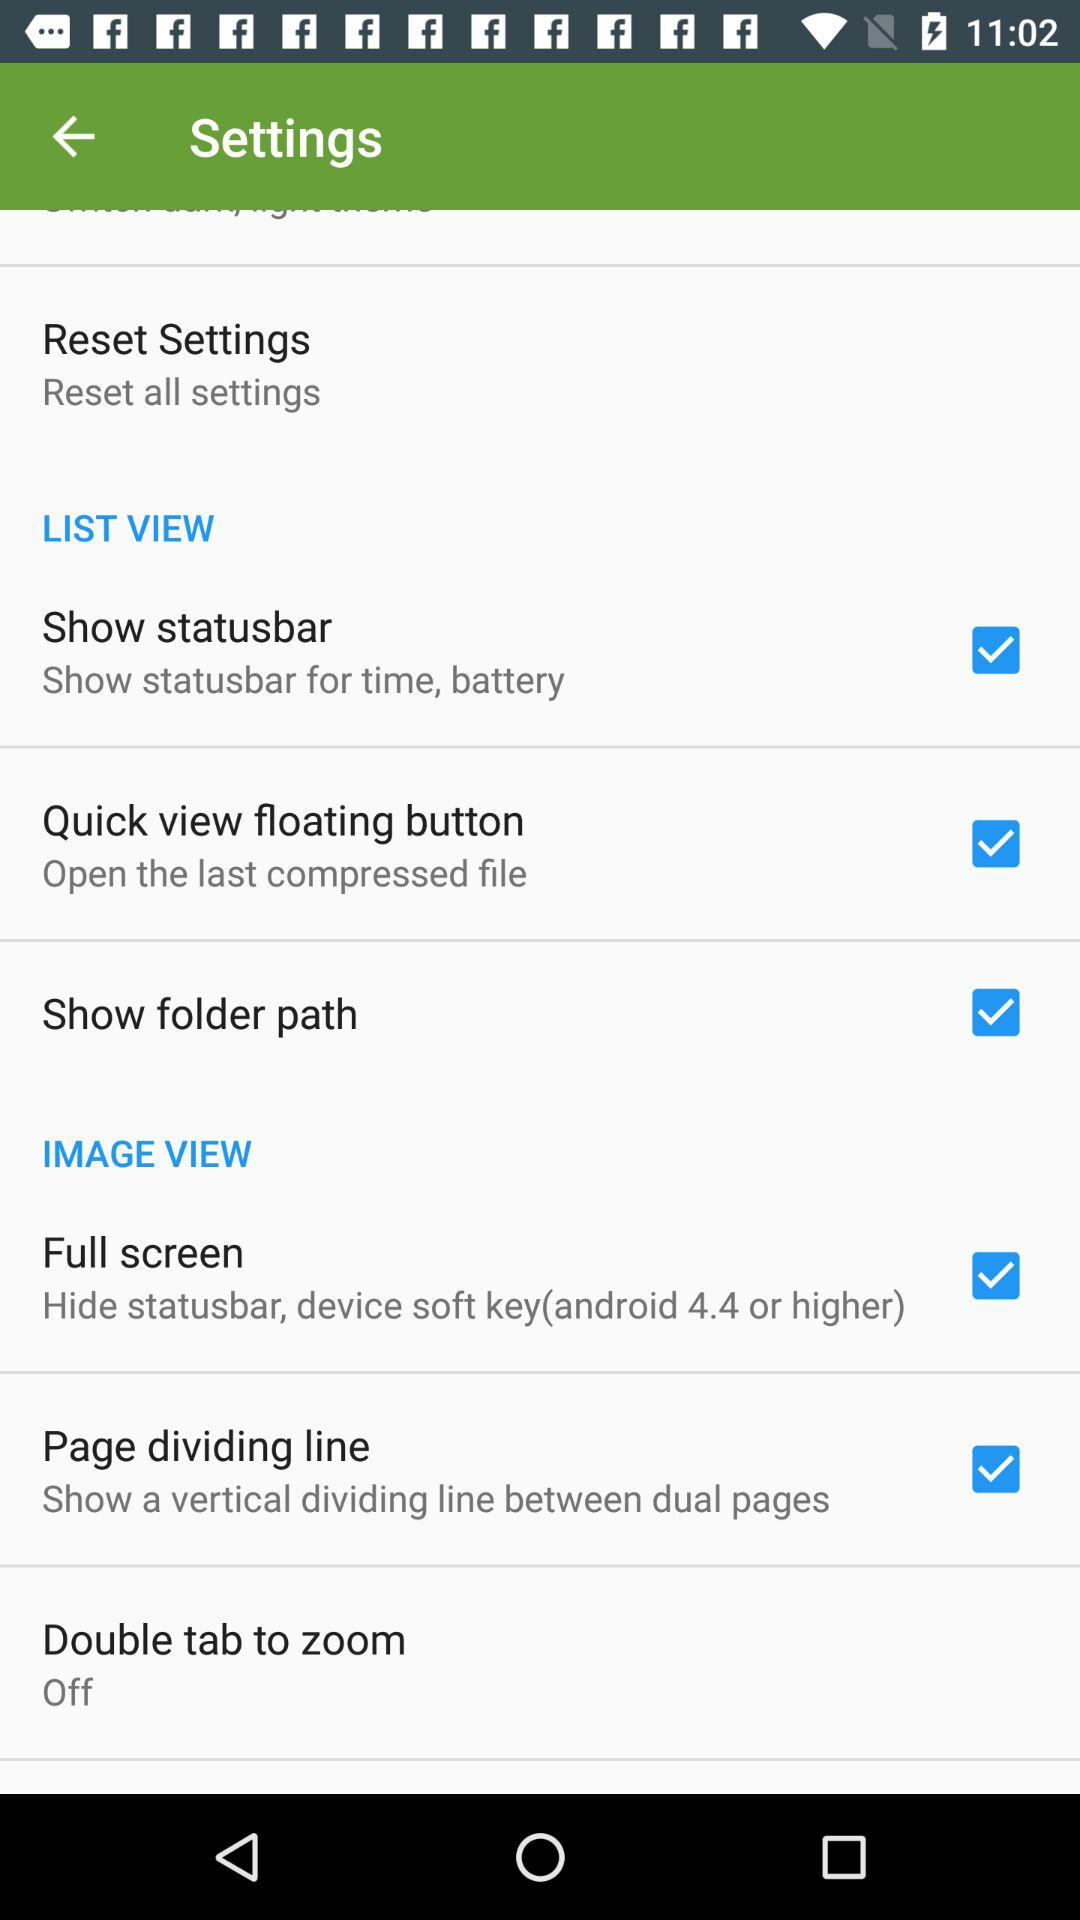What is the status of the Full Screen? The status is on. 